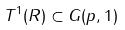<formula> <loc_0><loc_0><loc_500><loc_500>T ^ { 1 } ( R ) \subset G ( p , 1 )</formula> 